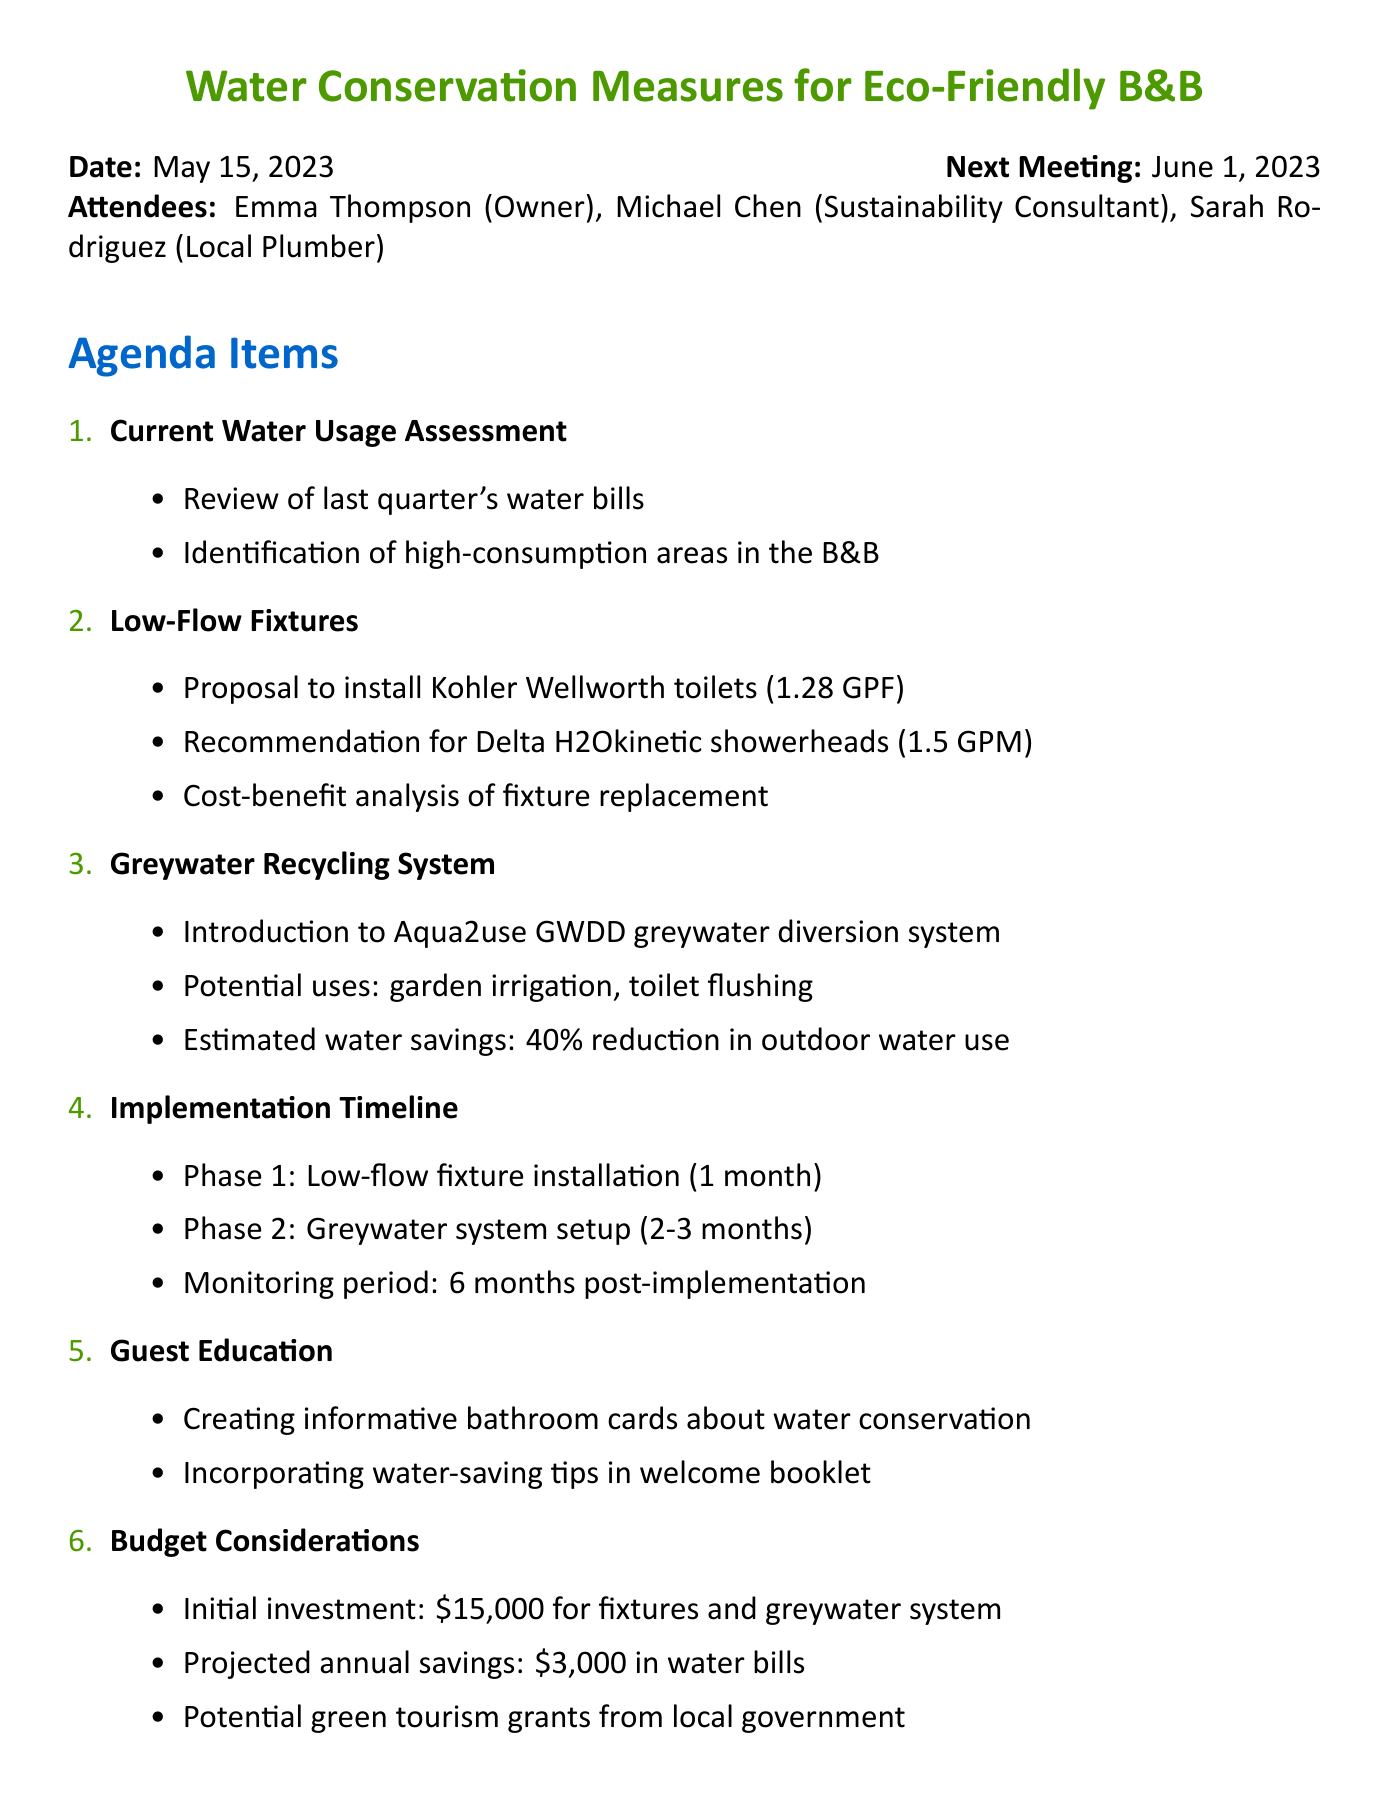What is the date of the meeting? The date of the meeting is mentioned at the top of the document.
Answer: May 15, 2023 Who is the sustainability consultant present in the meeting? The attendees list specifies the roles and names present at the meeting.
Answer: Michael Chen What is the projected annual savings from implementing the conservation measures? The budget considerations section outlines the projected financial savings.
Answer: $3,000 How much reduction in outdoor water use is estimated from the greywater recycling system? The estimated water savings is detailed in the greywater recycling system's discussion.
Answer: 40% What is the initial investment for the fixtures and greywater system? The budget considerations section specifies the cost of the initial investment.
Answer: $15,000 What phase will include the installation of low-flow fixtures? The implementation timeline section describes the phases of the project.
Answer: Phase 1 Who is responsible for assessing plumbing compatibility for new installations? The action items list states specific responsibilities assigned to attendees.
Answer: Sarah What is the name of the greywater diversion system introduced in the meeting? The greywater recycling system section provides the product name discussed.
Answer: Aqua2use GWDD 